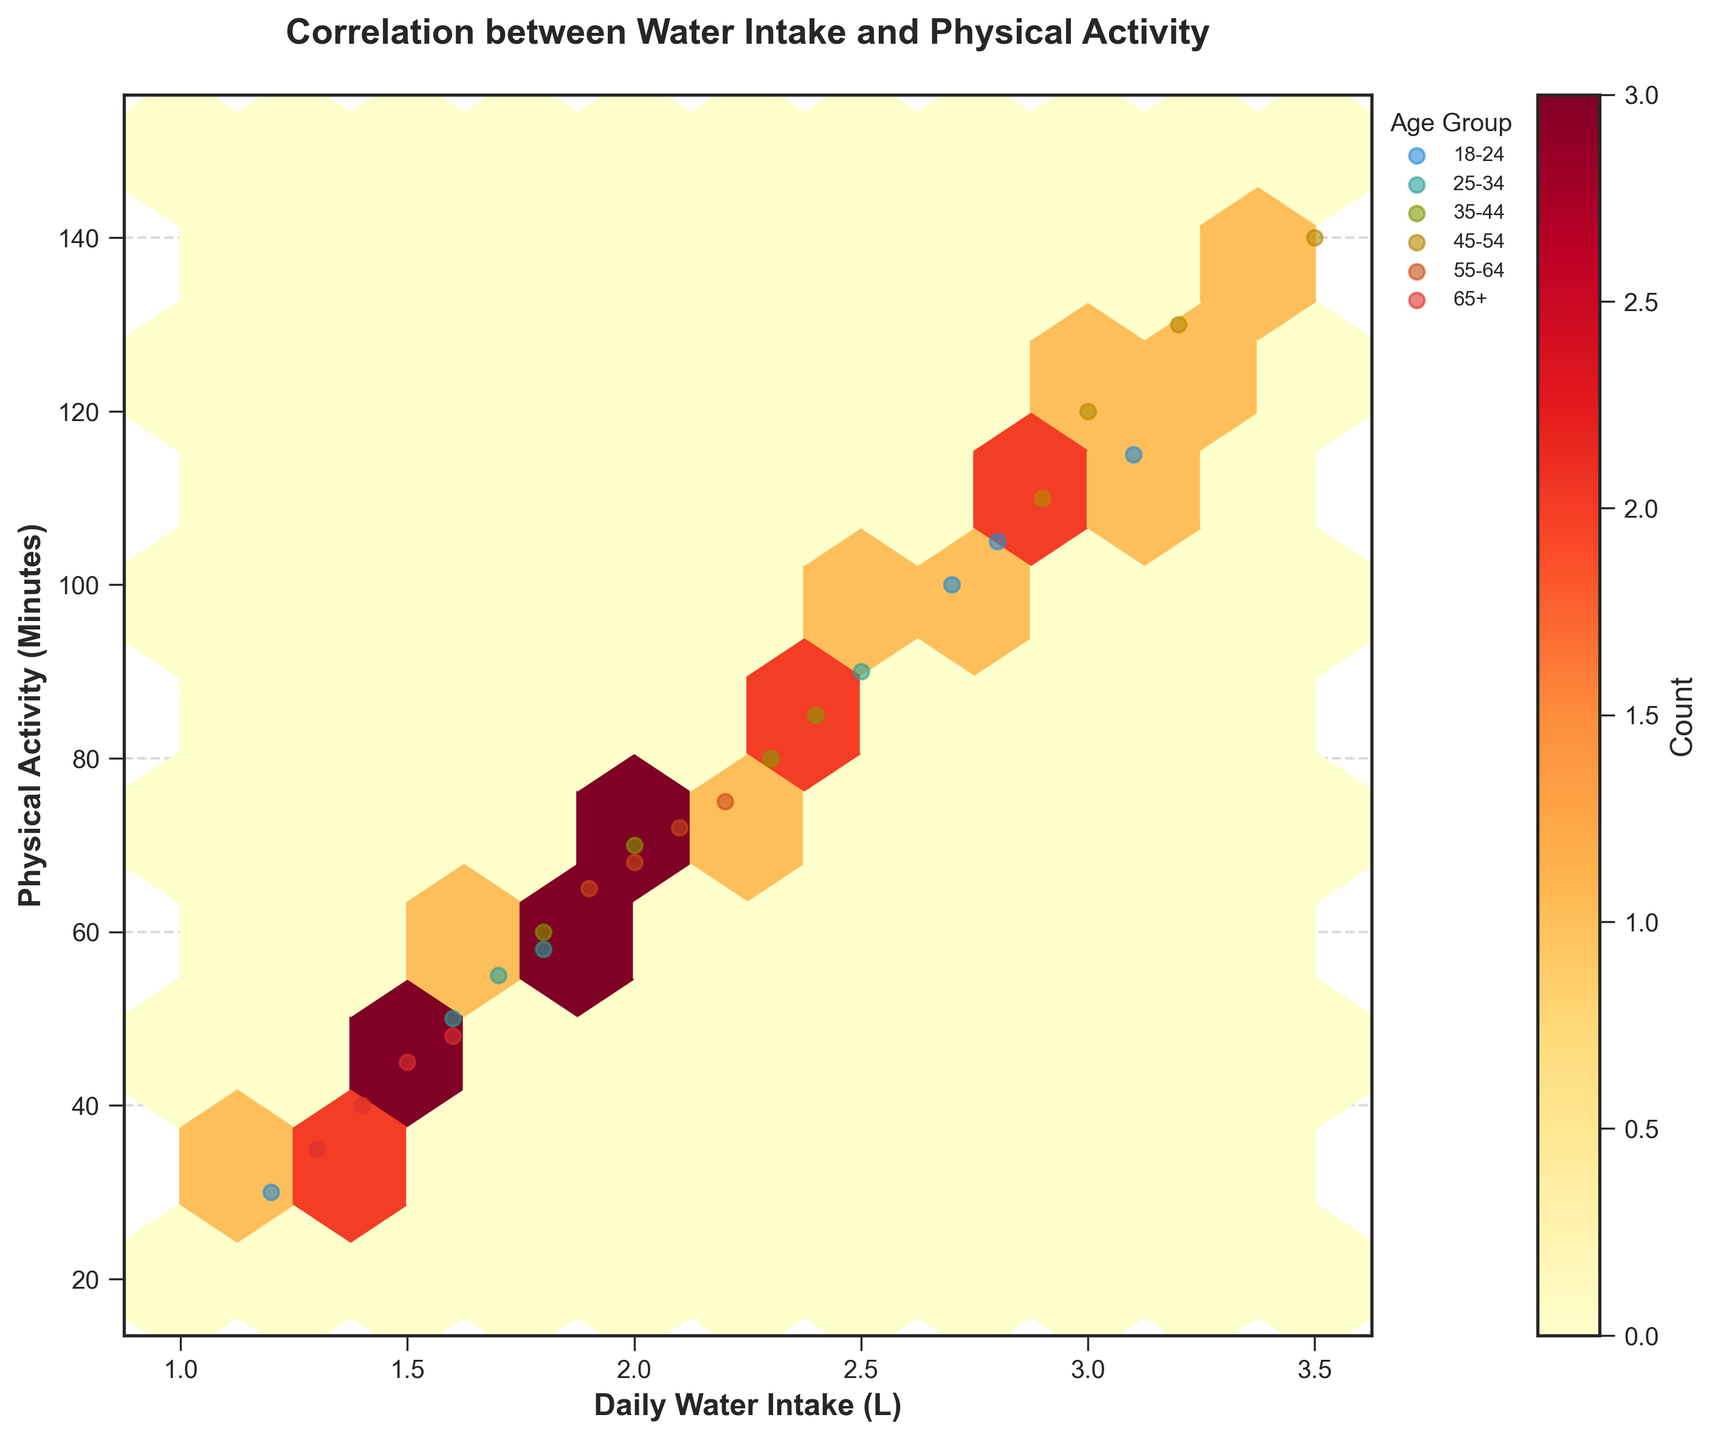What's the title of the plot? The title of the plot is displayed at the top center of the figure. It summarizes what the plot is about.
Answer: Correlation between Water Intake and Physical Activity What are the units of the x-axis and y-axis? The x-axis is labeled with "Daily Water Intake (L)" meaning it measures water intake in liters, and the y-axis is labeled "Physical Activity (Minutes)" meaning it measures activity in minutes.
Answer: Liters for x-axis, Minutes for y-axis Which age group has the highest visible water intake? By observing the scatter points over the hexbin plot, the highest water intake is indicated by the point farthest along the x-axis. This point is around 3.5 liters, and it belongs to the 45-54 age group.
Answer: 45-54 Does the plot show a correlation between water intake and physical activity? A positive correlation is suggested if higher water intakes are generally accompanied by higher physical activity minutes. The hexbin plot colors show density which tends to spread diagonally upward, indicating a trend.
Answer: Yes What is the count range depicted in the color bar? The color bar ranges from a lighter to darker shade of red, typically indicating a gradient. This gradient represents the count, visible on the figure's right side.
Answer: Low to high counts What age group has scatter points with the lowest physical activity levels? By observing the y-axis of the scatter points, the lowest physical activity level points are around 30 to 40 minutes. These points belong to both the 18-24 and 65+ age groups.
Answer: 65+ Which gender is more associated with higher physical activity levels in this plot? By comparing the scatter points distribution, males (typically marked as different color points or symbols) tend to cluster around higher physical activity levels than females.
Answer: Males What's the dominant age group with water intake around 2 liters per day? Look at the scatter points near the x-axis value of 2 liters. The color distribution suggests which age group appears more frequent. Points for the 55-64 age group are densest near this value.
Answer: 55-64 How many data points are represented maximum in one hexbin? The darkest hexbin color in the plot represents the highest count, which can be determined by the top value in the color bar. If the top count on the color bar is around 3-4, that's the maximum in one hexbin.
Answer: Around 4 